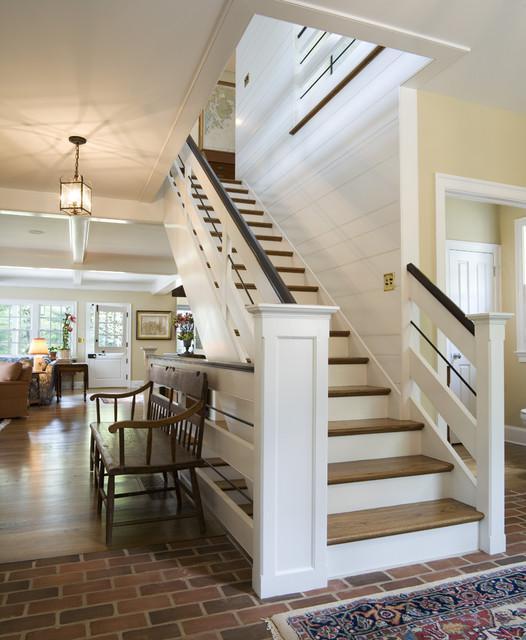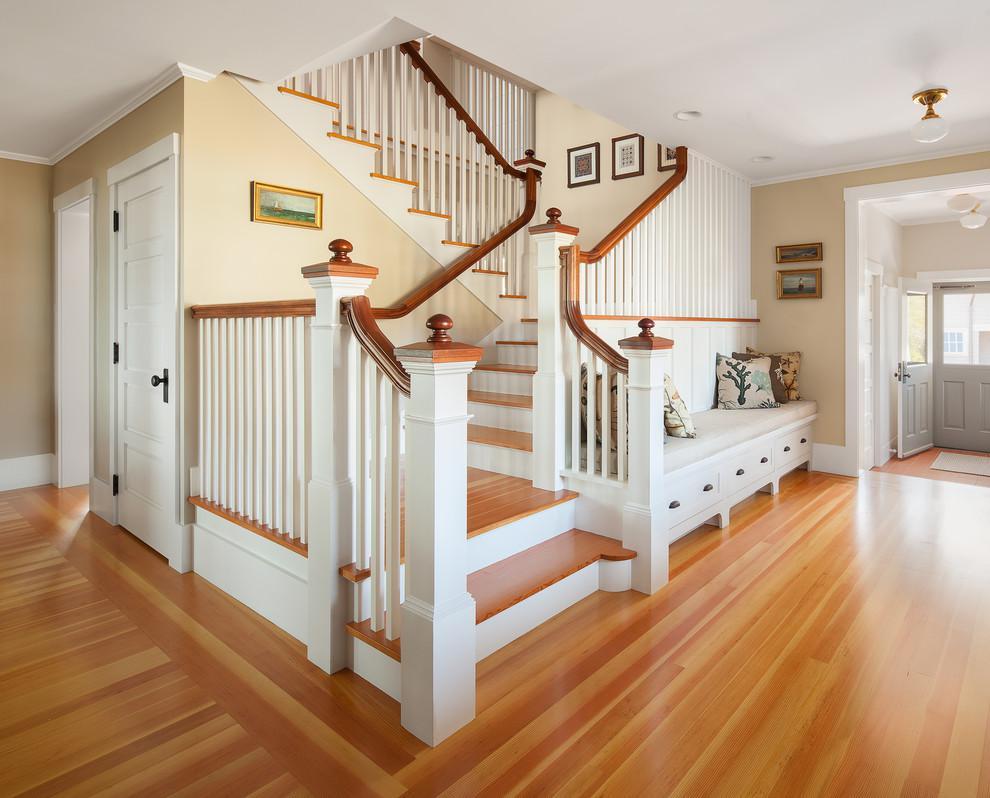The first image is the image on the left, the second image is the image on the right. Assess this claim about the two images: "The right image shows a staircase with white 'spindles' and a brown handrail that zigs and zags instead of ascending with no turns.". Correct or not? Answer yes or no. Yes. The first image is the image on the left, the second image is the image on the right. Examine the images to the left and right. Is the description "In at least  one image there is a winding stair care that is both white and wood brown." accurate? Answer yes or no. Yes. 